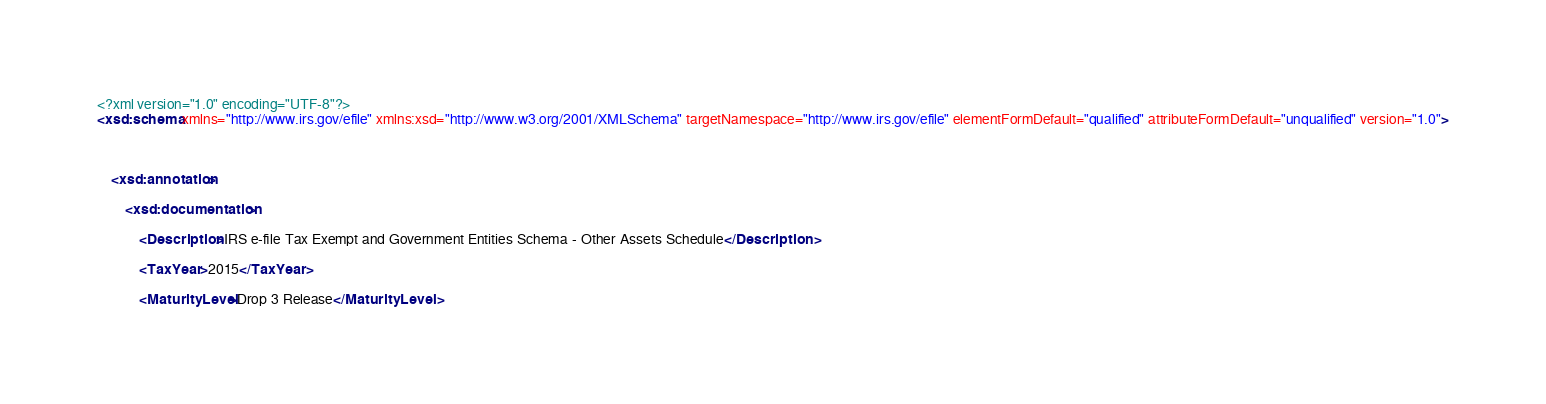Convert code to text. <code><loc_0><loc_0><loc_500><loc_500><_XML_><?xml version="1.0" encoding="UTF-8"?>
<xsd:schema xmlns="http://www.irs.gov/efile" xmlns:xsd="http://www.w3.org/2001/XMLSchema" targetNamespace="http://www.irs.gov/efile" elementFormDefault="qualified" attributeFormDefault="unqualified" version="1.0">



	<xsd:annotation>

		<xsd:documentation>

			<Description>IRS e-file Tax Exempt and Government Entities Schema - Other Assets Schedule</Description>

			<TaxYear>2015</TaxYear>

			<MaturityLevel>Drop 3 Release</MaturityLevel>
</code> 